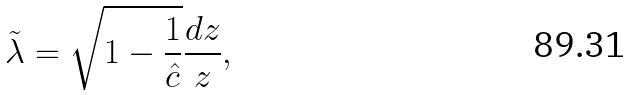Convert formula to latex. <formula><loc_0><loc_0><loc_500><loc_500>\tilde { \lambda } = \sqrt { 1 - \frac { 1 } { \hat { c } } } \frac { d z } { z } ,</formula> 